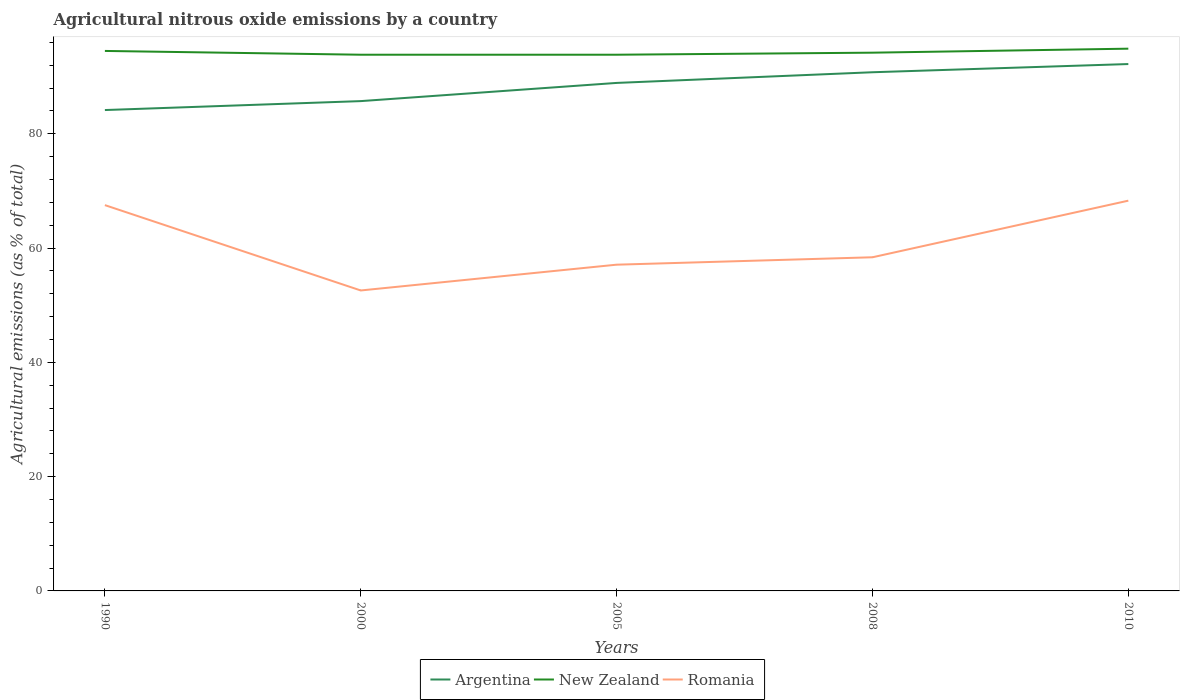Does the line corresponding to New Zealand intersect with the line corresponding to Romania?
Your answer should be compact. No. Across all years, what is the maximum amount of agricultural nitrous oxide emitted in New Zealand?
Your answer should be very brief. 93.85. In which year was the amount of agricultural nitrous oxide emitted in Argentina maximum?
Keep it short and to the point. 1990. What is the total amount of agricultural nitrous oxide emitted in Argentina in the graph?
Offer a terse response. -3.18. What is the difference between the highest and the second highest amount of agricultural nitrous oxide emitted in Romania?
Offer a terse response. 15.72. Is the amount of agricultural nitrous oxide emitted in Romania strictly greater than the amount of agricultural nitrous oxide emitted in New Zealand over the years?
Make the answer very short. Yes. How many lines are there?
Your answer should be very brief. 3. What is the difference between two consecutive major ticks on the Y-axis?
Provide a short and direct response. 20. Are the values on the major ticks of Y-axis written in scientific E-notation?
Offer a very short reply. No. Does the graph contain grids?
Make the answer very short. No. Where does the legend appear in the graph?
Offer a very short reply. Bottom center. How many legend labels are there?
Ensure brevity in your answer.  3. What is the title of the graph?
Keep it short and to the point. Agricultural nitrous oxide emissions by a country. What is the label or title of the Y-axis?
Your answer should be compact. Agricultural emissions (as % of total). What is the Agricultural emissions (as % of total) of Argentina in 1990?
Offer a very short reply. 84.16. What is the Agricultural emissions (as % of total) in New Zealand in 1990?
Your response must be concise. 94.51. What is the Agricultural emissions (as % of total) in Romania in 1990?
Offer a terse response. 67.52. What is the Agricultural emissions (as % of total) of Argentina in 2000?
Keep it short and to the point. 85.73. What is the Agricultural emissions (as % of total) of New Zealand in 2000?
Offer a terse response. 93.85. What is the Agricultural emissions (as % of total) of Romania in 2000?
Ensure brevity in your answer.  52.59. What is the Agricultural emissions (as % of total) in Argentina in 2005?
Offer a terse response. 88.91. What is the Agricultural emissions (as % of total) in New Zealand in 2005?
Ensure brevity in your answer.  93.85. What is the Agricultural emissions (as % of total) of Romania in 2005?
Give a very brief answer. 57.1. What is the Agricultural emissions (as % of total) in Argentina in 2008?
Your answer should be compact. 90.78. What is the Agricultural emissions (as % of total) in New Zealand in 2008?
Give a very brief answer. 94.21. What is the Agricultural emissions (as % of total) in Romania in 2008?
Give a very brief answer. 58.4. What is the Agricultural emissions (as % of total) in Argentina in 2010?
Keep it short and to the point. 92.22. What is the Agricultural emissions (as % of total) of New Zealand in 2010?
Provide a succinct answer. 94.91. What is the Agricultural emissions (as % of total) of Romania in 2010?
Provide a short and direct response. 68.3. Across all years, what is the maximum Agricultural emissions (as % of total) in Argentina?
Your answer should be very brief. 92.22. Across all years, what is the maximum Agricultural emissions (as % of total) in New Zealand?
Your response must be concise. 94.91. Across all years, what is the maximum Agricultural emissions (as % of total) in Romania?
Your response must be concise. 68.3. Across all years, what is the minimum Agricultural emissions (as % of total) of Argentina?
Offer a terse response. 84.16. Across all years, what is the minimum Agricultural emissions (as % of total) in New Zealand?
Your response must be concise. 93.85. Across all years, what is the minimum Agricultural emissions (as % of total) of Romania?
Ensure brevity in your answer.  52.59. What is the total Agricultural emissions (as % of total) of Argentina in the graph?
Provide a short and direct response. 441.8. What is the total Agricultural emissions (as % of total) in New Zealand in the graph?
Ensure brevity in your answer.  471.32. What is the total Agricultural emissions (as % of total) of Romania in the graph?
Make the answer very short. 303.91. What is the difference between the Agricultural emissions (as % of total) of Argentina in 1990 and that in 2000?
Provide a short and direct response. -1.56. What is the difference between the Agricultural emissions (as % of total) in New Zealand in 1990 and that in 2000?
Make the answer very short. 0.66. What is the difference between the Agricultural emissions (as % of total) of Romania in 1990 and that in 2000?
Make the answer very short. 14.94. What is the difference between the Agricultural emissions (as % of total) of Argentina in 1990 and that in 2005?
Your answer should be very brief. -4.75. What is the difference between the Agricultural emissions (as % of total) of New Zealand in 1990 and that in 2005?
Your response must be concise. 0.66. What is the difference between the Agricultural emissions (as % of total) in Romania in 1990 and that in 2005?
Make the answer very short. 10.42. What is the difference between the Agricultural emissions (as % of total) in Argentina in 1990 and that in 2008?
Your answer should be very brief. -6.62. What is the difference between the Agricultural emissions (as % of total) in New Zealand in 1990 and that in 2008?
Provide a succinct answer. 0.3. What is the difference between the Agricultural emissions (as % of total) of Romania in 1990 and that in 2008?
Offer a terse response. 9.13. What is the difference between the Agricultural emissions (as % of total) in Argentina in 1990 and that in 2010?
Your answer should be very brief. -8.05. What is the difference between the Agricultural emissions (as % of total) of New Zealand in 1990 and that in 2010?
Provide a succinct answer. -0.4. What is the difference between the Agricultural emissions (as % of total) of Romania in 1990 and that in 2010?
Provide a short and direct response. -0.78. What is the difference between the Agricultural emissions (as % of total) in Argentina in 2000 and that in 2005?
Give a very brief answer. -3.18. What is the difference between the Agricultural emissions (as % of total) of New Zealand in 2000 and that in 2005?
Give a very brief answer. 0. What is the difference between the Agricultural emissions (as % of total) in Romania in 2000 and that in 2005?
Your response must be concise. -4.51. What is the difference between the Agricultural emissions (as % of total) of Argentina in 2000 and that in 2008?
Provide a short and direct response. -5.05. What is the difference between the Agricultural emissions (as % of total) of New Zealand in 2000 and that in 2008?
Provide a succinct answer. -0.36. What is the difference between the Agricultural emissions (as % of total) in Romania in 2000 and that in 2008?
Ensure brevity in your answer.  -5.81. What is the difference between the Agricultural emissions (as % of total) of Argentina in 2000 and that in 2010?
Your response must be concise. -6.49. What is the difference between the Agricultural emissions (as % of total) in New Zealand in 2000 and that in 2010?
Keep it short and to the point. -1.06. What is the difference between the Agricultural emissions (as % of total) in Romania in 2000 and that in 2010?
Provide a succinct answer. -15.72. What is the difference between the Agricultural emissions (as % of total) of Argentina in 2005 and that in 2008?
Your response must be concise. -1.87. What is the difference between the Agricultural emissions (as % of total) of New Zealand in 2005 and that in 2008?
Provide a short and direct response. -0.36. What is the difference between the Agricultural emissions (as % of total) of Romania in 2005 and that in 2008?
Provide a short and direct response. -1.3. What is the difference between the Agricultural emissions (as % of total) of Argentina in 2005 and that in 2010?
Ensure brevity in your answer.  -3.3. What is the difference between the Agricultural emissions (as % of total) in New Zealand in 2005 and that in 2010?
Keep it short and to the point. -1.06. What is the difference between the Agricultural emissions (as % of total) in Romania in 2005 and that in 2010?
Keep it short and to the point. -11.2. What is the difference between the Agricultural emissions (as % of total) of Argentina in 2008 and that in 2010?
Provide a short and direct response. -1.44. What is the difference between the Agricultural emissions (as % of total) in New Zealand in 2008 and that in 2010?
Your response must be concise. -0.7. What is the difference between the Agricultural emissions (as % of total) of Romania in 2008 and that in 2010?
Offer a terse response. -9.91. What is the difference between the Agricultural emissions (as % of total) in Argentina in 1990 and the Agricultural emissions (as % of total) in New Zealand in 2000?
Your answer should be compact. -9.68. What is the difference between the Agricultural emissions (as % of total) in Argentina in 1990 and the Agricultural emissions (as % of total) in Romania in 2000?
Your response must be concise. 31.58. What is the difference between the Agricultural emissions (as % of total) of New Zealand in 1990 and the Agricultural emissions (as % of total) of Romania in 2000?
Keep it short and to the point. 41.92. What is the difference between the Agricultural emissions (as % of total) in Argentina in 1990 and the Agricultural emissions (as % of total) in New Zealand in 2005?
Provide a succinct answer. -9.68. What is the difference between the Agricultural emissions (as % of total) of Argentina in 1990 and the Agricultural emissions (as % of total) of Romania in 2005?
Provide a succinct answer. 27.06. What is the difference between the Agricultural emissions (as % of total) of New Zealand in 1990 and the Agricultural emissions (as % of total) of Romania in 2005?
Offer a terse response. 37.41. What is the difference between the Agricultural emissions (as % of total) of Argentina in 1990 and the Agricultural emissions (as % of total) of New Zealand in 2008?
Your answer should be very brief. -10.04. What is the difference between the Agricultural emissions (as % of total) of Argentina in 1990 and the Agricultural emissions (as % of total) of Romania in 2008?
Your answer should be very brief. 25.77. What is the difference between the Agricultural emissions (as % of total) of New Zealand in 1990 and the Agricultural emissions (as % of total) of Romania in 2008?
Keep it short and to the point. 36.11. What is the difference between the Agricultural emissions (as % of total) in Argentina in 1990 and the Agricultural emissions (as % of total) in New Zealand in 2010?
Offer a very short reply. -10.74. What is the difference between the Agricultural emissions (as % of total) in Argentina in 1990 and the Agricultural emissions (as % of total) in Romania in 2010?
Provide a succinct answer. 15.86. What is the difference between the Agricultural emissions (as % of total) of New Zealand in 1990 and the Agricultural emissions (as % of total) of Romania in 2010?
Your answer should be compact. 26.21. What is the difference between the Agricultural emissions (as % of total) in Argentina in 2000 and the Agricultural emissions (as % of total) in New Zealand in 2005?
Give a very brief answer. -8.12. What is the difference between the Agricultural emissions (as % of total) in Argentina in 2000 and the Agricultural emissions (as % of total) in Romania in 2005?
Your response must be concise. 28.63. What is the difference between the Agricultural emissions (as % of total) of New Zealand in 2000 and the Agricultural emissions (as % of total) of Romania in 2005?
Make the answer very short. 36.75. What is the difference between the Agricultural emissions (as % of total) of Argentina in 2000 and the Agricultural emissions (as % of total) of New Zealand in 2008?
Give a very brief answer. -8.48. What is the difference between the Agricultural emissions (as % of total) in Argentina in 2000 and the Agricultural emissions (as % of total) in Romania in 2008?
Ensure brevity in your answer.  27.33. What is the difference between the Agricultural emissions (as % of total) of New Zealand in 2000 and the Agricultural emissions (as % of total) of Romania in 2008?
Your answer should be very brief. 35.45. What is the difference between the Agricultural emissions (as % of total) in Argentina in 2000 and the Agricultural emissions (as % of total) in New Zealand in 2010?
Give a very brief answer. -9.18. What is the difference between the Agricultural emissions (as % of total) in Argentina in 2000 and the Agricultural emissions (as % of total) in Romania in 2010?
Your answer should be compact. 17.42. What is the difference between the Agricultural emissions (as % of total) in New Zealand in 2000 and the Agricultural emissions (as % of total) in Romania in 2010?
Provide a succinct answer. 25.54. What is the difference between the Agricultural emissions (as % of total) of Argentina in 2005 and the Agricultural emissions (as % of total) of New Zealand in 2008?
Make the answer very short. -5.29. What is the difference between the Agricultural emissions (as % of total) of Argentina in 2005 and the Agricultural emissions (as % of total) of Romania in 2008?
Offer a very short reply. 30.51. What is the difference between the Agricultural emissions (as % of total) in New Zealand in 2005 and the Agricultural emissions (as % of total) in Romania in 2008?
Make the answer very short. 35.45. What is the difference between the Agricultural emissions (as % of total) in Argentina in 2005 and the Agricultural emissions (as % of total) in New Zealand in 2010?
Provide a short and direct response. -6. What is the difference between the Agricultural emissions (as % of total) of Argentina in 2005 and the Agricultural emissions (as % of total) of Romania in 2010?
Give a very brief answer. 20.61. What is the difference between the Agricultural emissions (as % of total) of New Zealand in 2005 and the Agricultural emissions (as % of total) of Romania in 2010?
Provide a short and direct response. 25.54. What is the difference between the Agricultural emissions (as % of total) of Argentina in 2008 and the Agricultural emissions (as % of total) of New Zealand in 2010?
Provide a succinct answer. -4.13. What is the difference between the Agricultural emissions (as % of total) in Argentina in 2008 and the Agricultural emissions (as % of total) in Romania in 2010?
Provide a short and direct response. 22.48. What is the difference between the Agricultural emissions (as % of total) in New Zealand in 2008 and the Agricultural emissions (as % of total) in Romania in 2010?
Provide a succinct answer. 25.9. What is the average Agricultural emissions (as % of total) in Argentina per year?
Offer a very short reply. 88.36. What is the average Agricultural emissions (as % of total) of New Zealand per year?
Your answer should be compact. 94.26. What is the average Agricultural emissions (as % of total) of Romania per year?
Provide a short and direct response. 60.78. In the year 1990, what is the difference between the Agricultural emissions (as % of total) of Argentina and Agricultural emissions (as % of total) of New Zealand?
Offer a terse response. -10.35. In the year 1990, what is the difference between the Agricultural emissions (as % of total) in Argentina and Agricultural emissions (as % of total) in Romania?
Your response must be concise. 16.64. In the year 1990, what is the difference between the Agricultural emissions (as % of total) of New Zealand and Agricultural emissions (as % of total) of Romania?
Offer a terse response. 26.99. In the year 2000, what is the difference between the Agricultural emissions (as % of total) in Argentina and Agricultural emissions (as % of total) in New Zealand?
Provide a short and direct response. -8.12. In the year 2000, what is the difference between the Agricultural emissions (as % of total) of Argentina and Agricultural emissions (as % of total) of Romania?
Ensure brevity in your answer.  33.14. In the year 2000, what is the difference between the Agricultural emissions (as % of total) of New Zealand and Agricultural emissions (as % of total) of Romania?
Your answer should be very brief. 41.26. In the year 2005, what is the difference between the Agricultural emissions (as % of total) of Argentina and Agricultural emissions (as % of total) of New Zealand?
Your answer should be very brief. -4.93. In the year 2005, what is the difference between the Agricultural emissions (as % of total) in Argentina and Agricultural emissions (as % of total) in Romania?
Your answer should be compact. 31.81. In the year 2005, what is the difference between the Agricultural emissions (as % of total) of New Zealand and Agricultural emissions (as % of total) of Romania?
Keep it short and to the point. 36.75. In the year 2008, what is the difference between the Agricultural emissions (as % of total) of Argentina and Agricultural emissions (as % of total) of New Zealand?
Provide a short and direct response. -3.43. In the year 2008, what is the difference between the Agricultural emissions (as % of total) in Argentina and Agricultural emissions (as % of total) in Romania?
Your answer should be compact. 32.38. In the year 2008, what is the difference between the Agricultural emissions (as % of total) of New Zealand and Agricultural emissions (as % of total) of Romania?
Your answer should be very brief. 35.81. In the year 2010, what is the difference between the Agricultural emissions (as % of total) of Argentina and Agricultural emissions (as % of total) of New Zealand?
Offer a terse response. -2.69. In the year 2010, what is the difference between the Agricultural emissions (as % of total) in Argentina and Agricultural emissions (as % of total) in Romania?
Your answer should be compact. 23.91. In the year 2010, what is the difference between the Agricultural emissions (as % of total) of New Zealand and Agricultural emissions (as % of total) of Romania?
Make the answer very short. 26.6. What is the ratio of the Agricultural emissions (as % of total) in Argentina in 1990 to that in 2000?
Offer a very short reply. 0.98. What is the ratio of the Agricultural emissions (as % of total) in New Zealand in 1990 to that in 2000?
Your answer should be very brief. 1.01. What is the ratio of the Agricultural emissions (as % of total) in Romania in 1990 to that in 2000?
Offer a terse response. 1.28. What is the ratio of the Agricultural emissions (as % of total) of Argentina in 1990 to that in 2005?
Give a very brief answer. 0.95. What is the ratio of the Agricultural emissions (as % of total) in New Zealand in 1990 to that in 2005?
Make the answer very short. 1.01. What is the ratio of the Agricultural emissions (as % of total) of Romania in 1990 to that in 2005?
Offer a terse response. 1.18. What is the ratio of the Agricultural emissions (as % of total) in Argentina in 1990 to that in 2008?
Provide a short and direct response. 0.93. What is the ratio of the Agricultural emissions (as % of total) of New Zealand in 1990 to that in 2008?
Ensure brevity in your answer.  1. What is the ratio of the Agricultural emissions (as % of total) of Romania in 1990 to that in 2008?
Offer a terse response. 1.16. What is the ratio of the Agricultural emissions (as % of total) in Argentina in 1990 to that in 2010?
Offer a very short reply. 0.91. What is the ratio of the Agricultural emissions (as % of total) in Argentina in 2000 to that in 2005?
Ensure brevity in your answer.  0.96. What is the ratio of the Agricultural emissions (as % of total) in Romania in 2000 to that in 2005?
Provide a short and direct response. 0.92. What is the ratio of the Agricultural emissions (as % of total) of Argentina in 2000 to that in 2008?
Provide a short and direct response. 0.94. What is the ratio of the Agricultural emissions (as % of total) of New Zealand in 2000 to that in 2008?
Provide a succinct answer. 1. What is the ratio of the Agricultural emissions (as % of total) in Romania in 2000 to that in 2008?
Keep it short and to the point. 0.9. What is the ratio of the Agricultural emissions (as % of total) of Argentina in 2000 to that in 2010?
Provide a short and direct response. 0.93. What is the ratio of the Agricultural emissions (as % of total) in New Zealand in 2000 to that in 2010?
Provide a short and direct response. 0.99. What is the ratio of the Agricultural emissions (as % of total) in Romania in 2000 to that in 2010?
Provide a short and direct response. 0.77. What is the ratio of the Agricultural emissions (as % of total) of Argentina in 2005 to that in 2008?
Provide a short and direct response. 0.98. What is the ratio of the Agricultural emissions (as % of total) of New Zealand in 2005 to that in 2008?
Offer a terse response. 1. What is the ratio of the Agricultural emissions (as % of total) in Romania in 2005 to that in 2008?
Keep it short and to the point. 0.98. What is the ratio of the Agricultural emissions (as % of total) of Argentina in 2005 to that in 2010?
Give a very brief answer. 0.96. What is the ratio of the Agricultural emissions (as % of total) in Romania in 2005 to that in 2010?
Your answer should be compact. 0.84. What is the ratio of the Agricultural emissions (as % of total) of Argentina in 2008 to that in 2010?
Your answer should be compact. 0.98. What is the ratio of the Agricultural emissions (as % of total) in New Zealand in 2008 to that in 2010?
Ensure brevity in your answer.  0.99. What is the ratio of the Agricultural emissions (as % of total) of Romania in 2008 to that in 2010?
Provide a short and direct response. 0.85. What is the difference between the highest and the second highest Agricultural emissions (as % of total) in Argentina?
Ensure brevity in your answer.  1.44. What is the difference between the highest and the second highest Agricultural emissions (as % of total) of New Zealand?
Offer a very short reply. 0.4. What is the difference between the highest and the second highest Agricultural emissions (as % of total) of Romania?
Keep it short and to the point. 0.78. What is the difference between the highest and the lowest Agricultural emissions (as % of total) of Argentina?
Make the answer very short. 8.05. What is the difference between the highest and the lowest Agricultural emissions (as % of total) of New Zealand?
Offer a very short reply. 1.06. What is the difference between the highest and the lowest Agricultural emissions (as % of total) of Romania?
Make the answer very short. 15.72. 